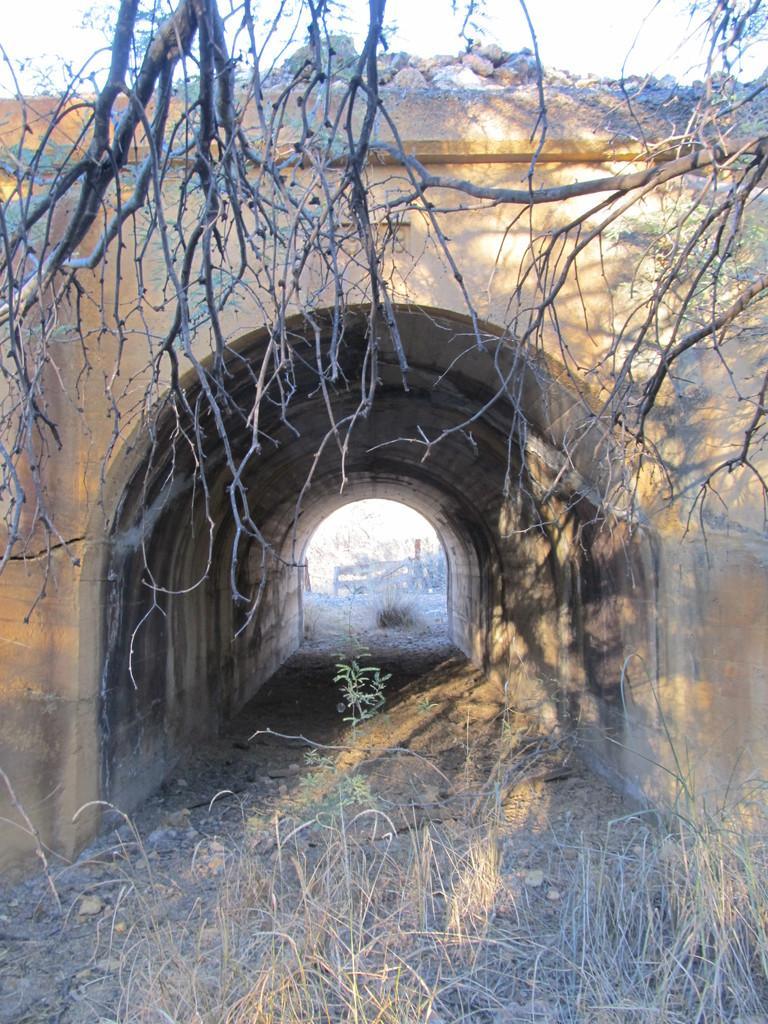Please provide a concise description of this image. In the foreground of this image, there are dry plants at the bottom and a tree without leaves at the top. In the middle, there is an arch to a wall and we can also see stones and sky at the top. 